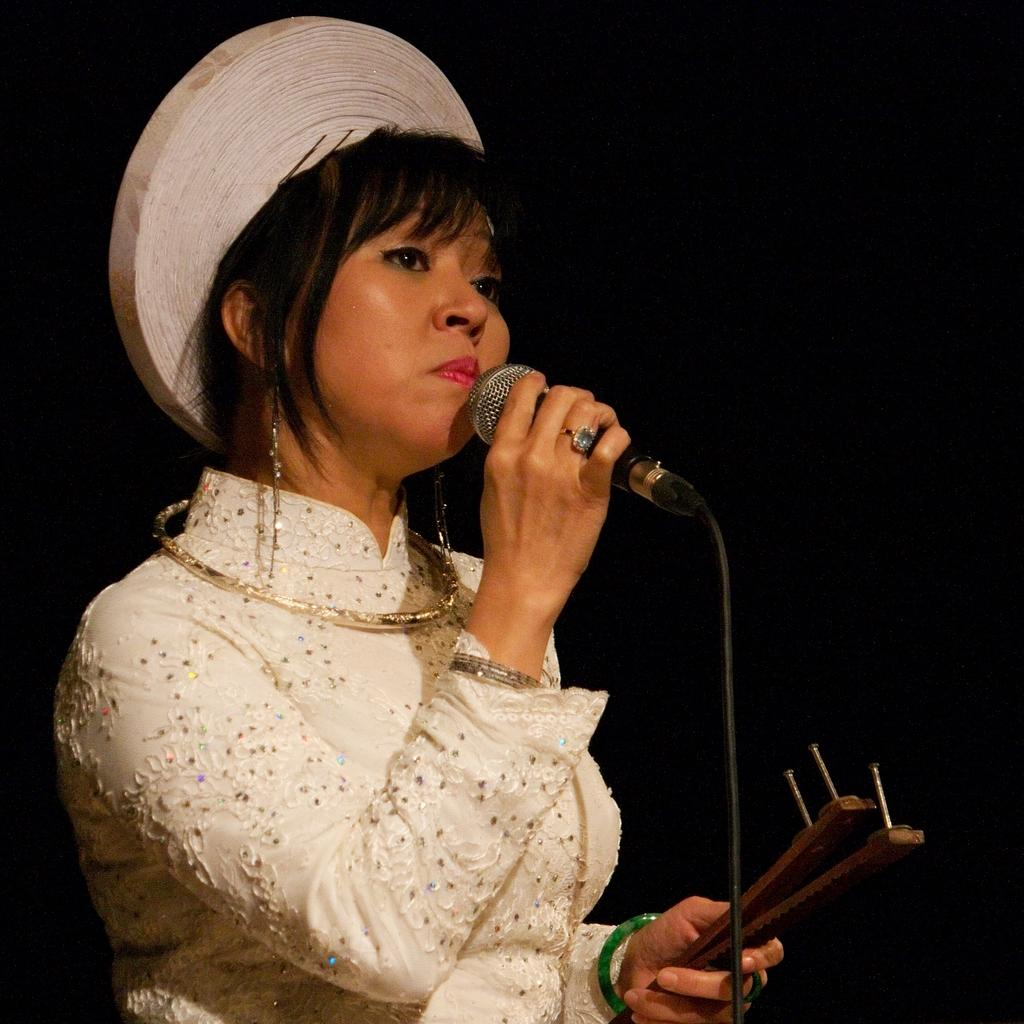Who is the main subject in the image? There is a lady in the image. What is the lady holding in the image? The lady is holding a mic. What is the lady wearing on her head? The lady is wearing a white cap. What color is the dress the lady is wearing? The lady is wearing a white dress. What type of oatmeal is the lady eating in the image? There is no oatmeal present in the image; the lady is holding a mic and wearing a white dress and cap. 